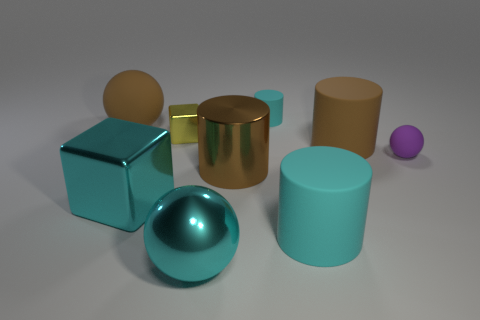Subtract all brown matte cylinders. How many cylinders are left? 3 Add 1 cyan rubber cylinders. How many objects exist? 10 Subtract all balls. How many objects are left? 6 Subtract all cyan cylinders. How many cylinders are left? 2 Subtract 1 cylinders. How many cylinders are left? 3 Subtract all yellow cylinders. Subtract all brown cubes. How many cylinders are left? 4 Subtract all brown balls. How many brown cylinders are left? 2 Subtract all small matte cylinders. Subtract all tiny spheres. How many objects are left? 7 Add 2 yellow metallic blocks. How many yellow metallic blocks are left? 3 Add 5 yellow rubber things. How many yellow rubber things exist? 5 